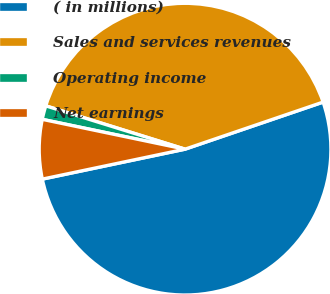<chart> <loc_0><loc_0><loc_500><loc_500><pie_chart><fcel>( in millions)<fcel>Sales and services revenues<fcel>Operating income<fcel>Net earnings<nl><fcel>51.94%<fcel>39.97%<fcel>1.52%<fcel>6.57%<nl></chart> 